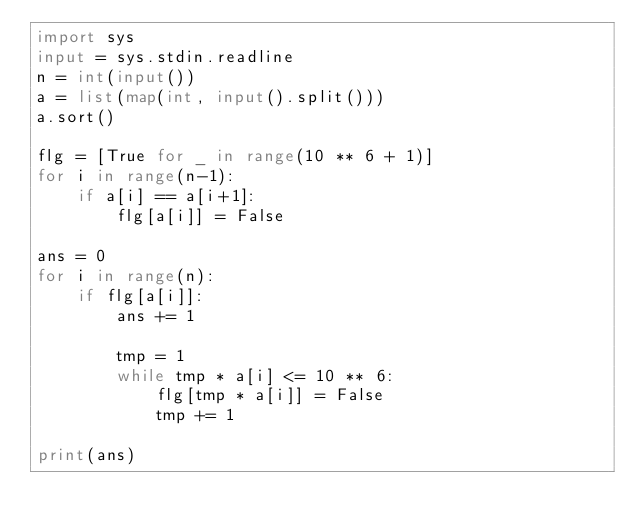Convert code to text. <code><loc_0><loc_0><loc_500><loc_500><_Python_>import sys
input = sys.stdin.readline
n = int(input())
a = list(map(int, input().split()))
a.sort()

flg = [True for _ in range(10 ** 6 + 1)]
for i in range(n-1):
    if a[i] == a[i+1]:
        flg[a[i]] = False

ans = 0
for i in range(n):
    if flg[a[i]]:
        ans += 1

        tmp = 1
        while tmp * a[i] <= 10 ** 6:
            flg[tmp * a[i]] = False
            tmp += 1

print(ans)</code> 